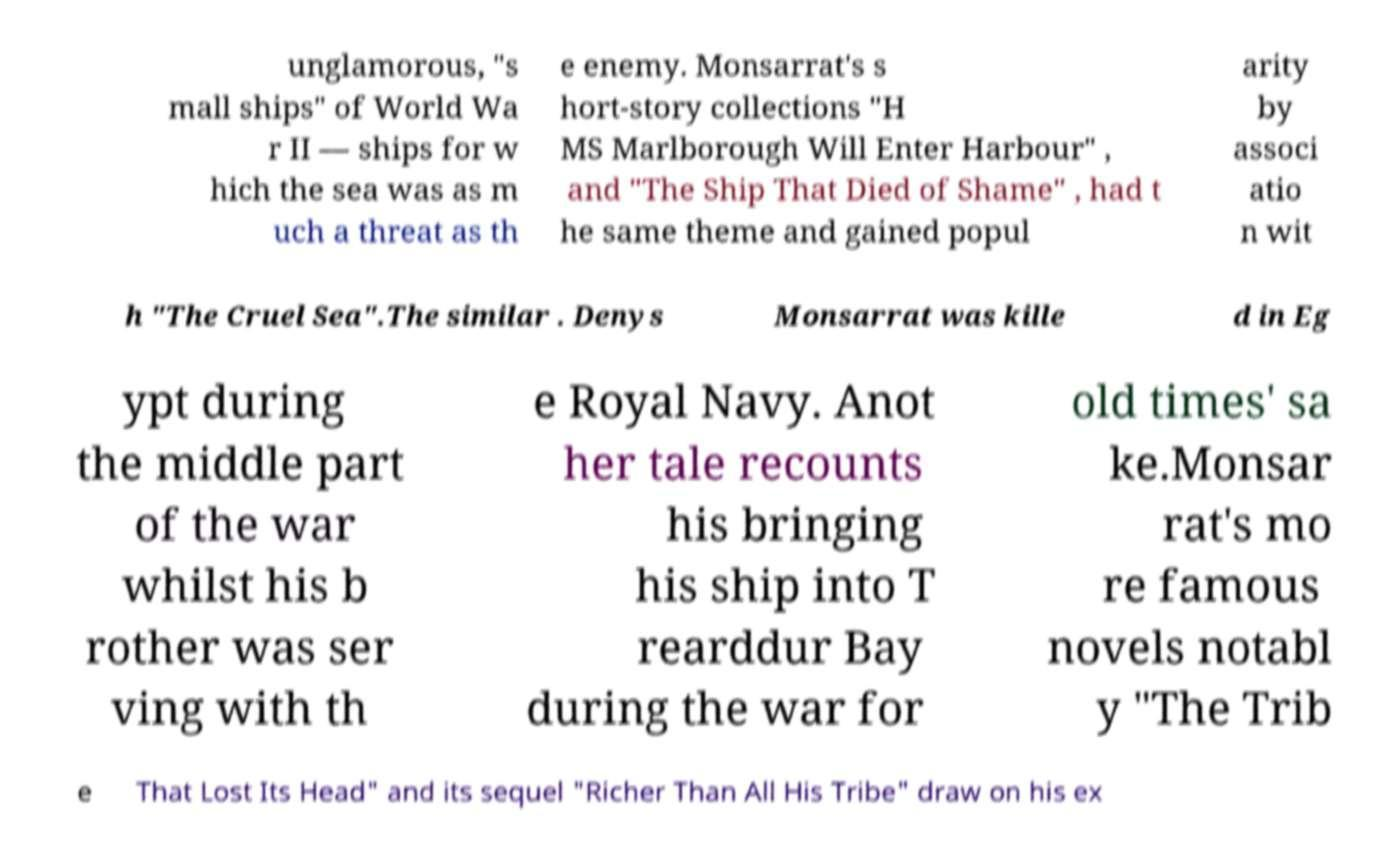There's text embedded in this image that I need extracted. Can you transcribe it verbatim? unglamorous, "s mall ships" of World Wa r II — ships for w hich the sea was as m uch a threat as th e enemy. Monsarrat's s hort-story collections "H MS Marlborough Will Enter Harbour" , and "The Ship That Died of Shame" , had t he same theme and gained popul arity by associ atio n wit h "The Cruel Sea".The similar . Denys Monsarrat was kille d in Eg ypt during the middle part of the war whilst his b rother was ser ving with th e Royal Navy. Anot her tale recounts his bringing his ship into T rearddur Bay during the war for old times' sa ke.Monsar rat's mo re famous novels notabl y "The Trib e That Lost Its Head" and its sequel "Richer Than All His Tribe" draw on his ex 